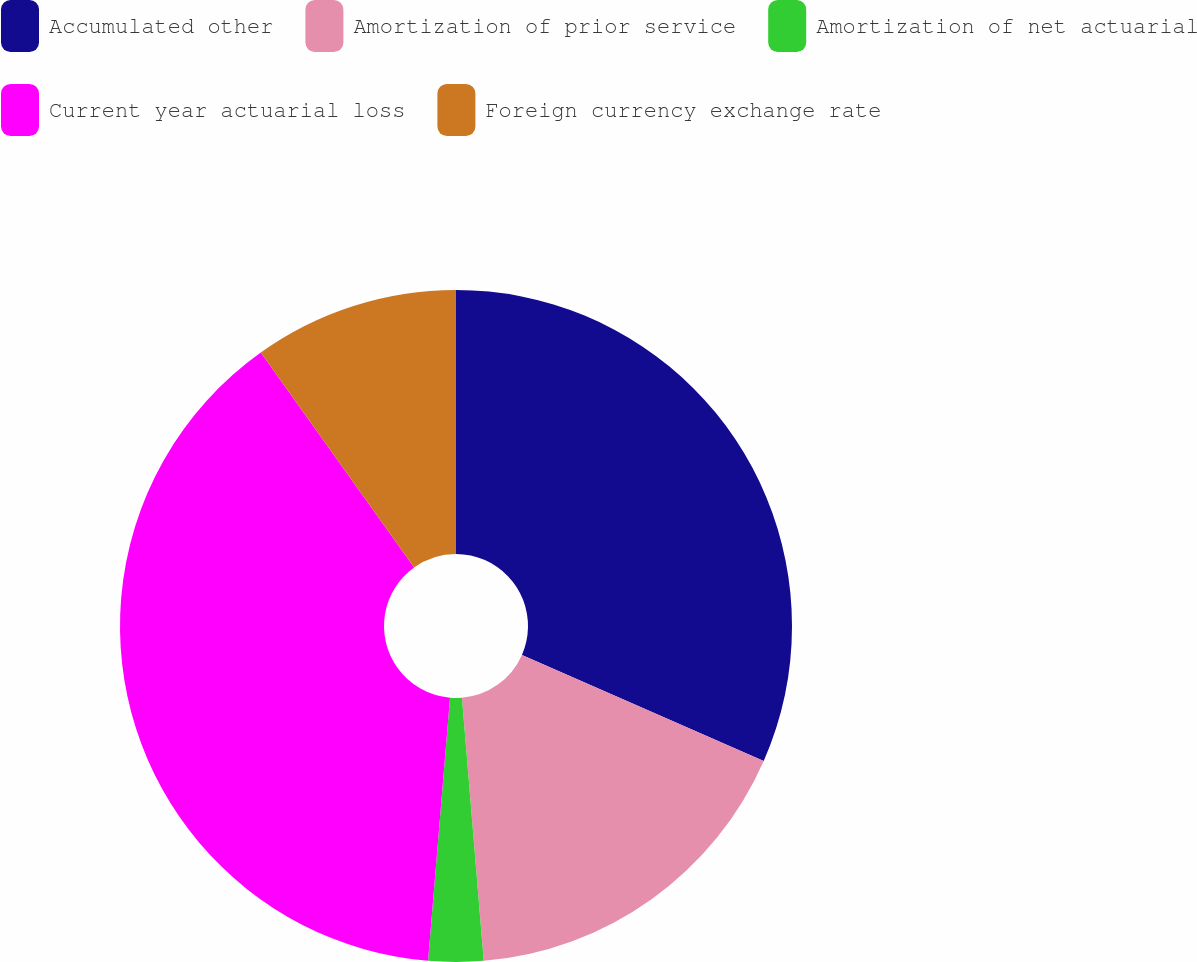<chart> <loc_0><loc_0><loc_500><loc_500><pie_chart><fcel>Accumulated other<fcel>Amortization of prior service<fcel>Amortization of net actuarial<fcel>Current year actuarial loss<fcel>Foreign currency exchange rate<nl><fcel>31.58%<fcel>17.11%<fcel>2.64%<fcel>38.81%<fcel>9.87%<nl></chart> 